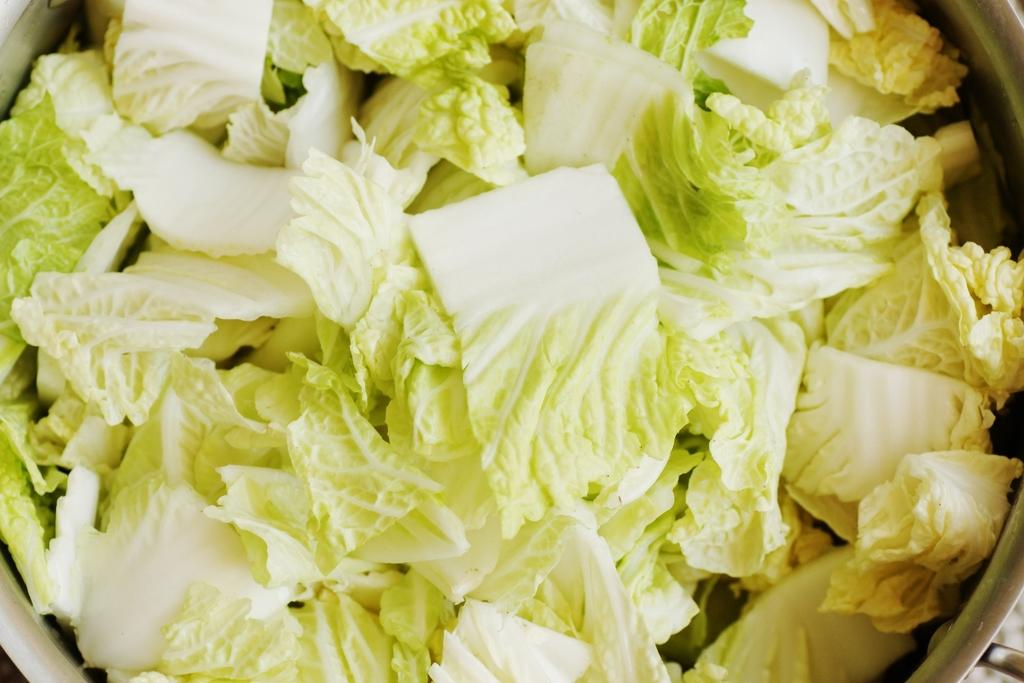What is in the bowl that is visible in the image? There is a bowl in the image, and it contains cauliflower pieces. Can you describe the contents of the bowl in more detail? The bowl contains cauliflower pieces, which are pieces of the vegetable cauliflower. What type of vein is visible in the image? There is no vein visible in the image; the image only contains a bowl with cauliflower pieces. 